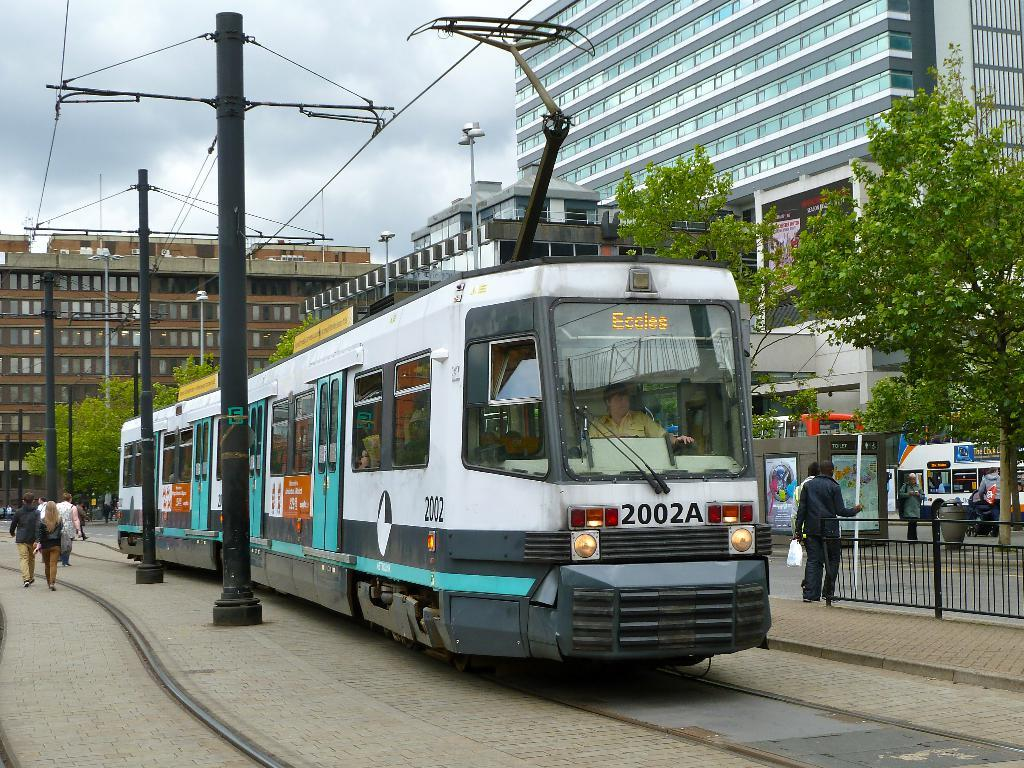<image>
Summarize the visual content of the image. A trolley bus with 2002A on the front of it. 